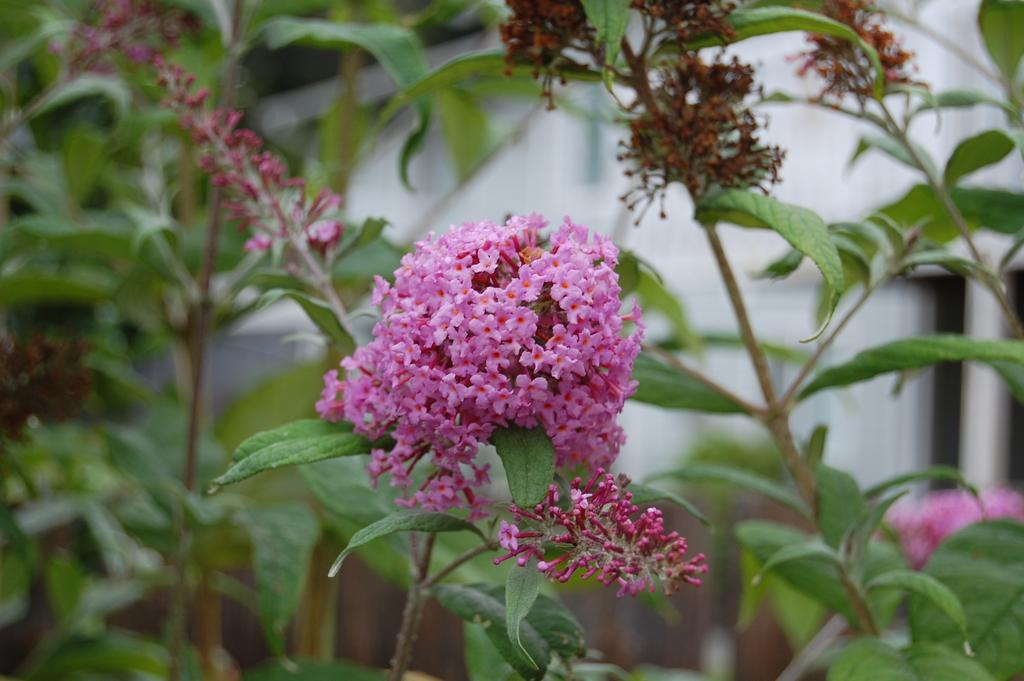What type of plant life is visible in the image? There are flowers, leaves, and branches in the image. Can you describe the background of the image? The background of the image is blurry. What type of tramp can be seen in the image? There is no tramp present in the image; it features plant life and a blurry background. What store is visible in the image? There is no store present in the image. 